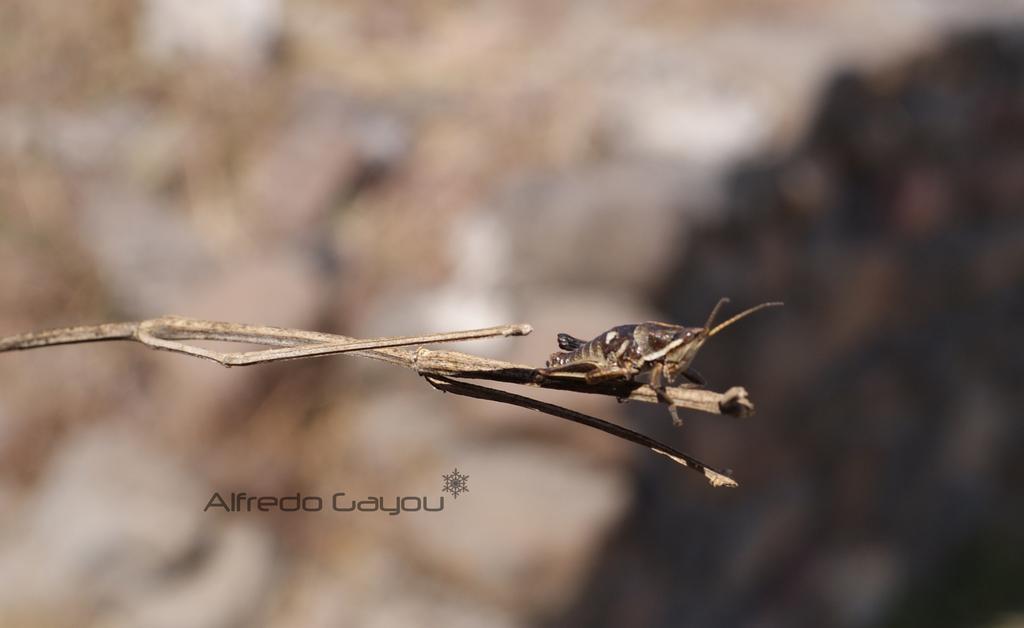Please provide a concise description of this image. In the foreground I can see an insect on the branch of a tree and a text. The background is white and brown in color. This image is taken may be during a day. 